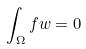Convert formula to latex. <formula><loc_0><loc_0><loc_500><loc_500>\int _ { \Omega } f w = 0</formula> 